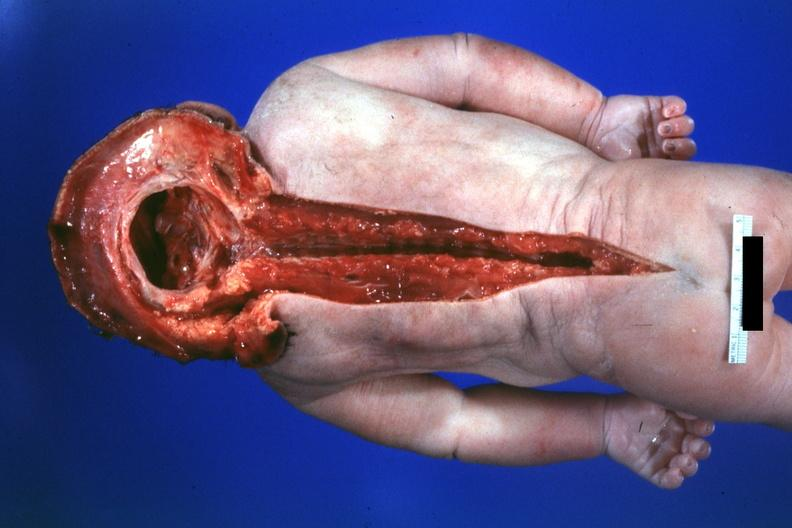what lived one day?
Answer the question using a single word or phrase. No chromosomal defects 